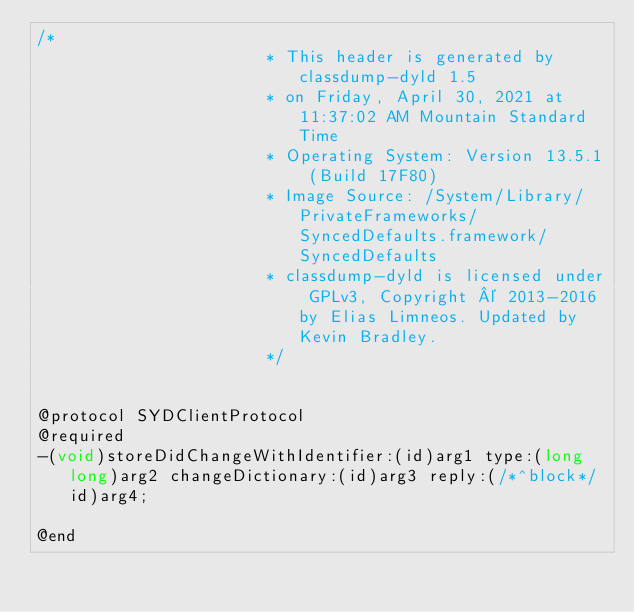<code> <loc_0><loc_0><loc_500><loc_500><_C_>/*
                       * This header is generated by classdump-dyld 1.5
                       * on Friday, April 30, 2021 at 11:37:02 AM Mountain Standard Time
                       * Operating System: Version 13.5.1 (Build 17F80)
                       * Image Source: /System/Library/PrivateFrameworks/SyncedDefaults.framework/SyncedDefaults
                       * classdump-dyld is licensed under GPLv3, Copyright © 2013-2016 by Elias Limneos. Updated by Kevin Bradley.
                       */


@protocol SYDClientProtocol
@required
-(void)storeDidChangeWithIdentifier:(id)arg1 type:(long long)arg2 changeDictionary:(id)arg3 reply:(/*^block*/id)arg4;

@end

</code> 